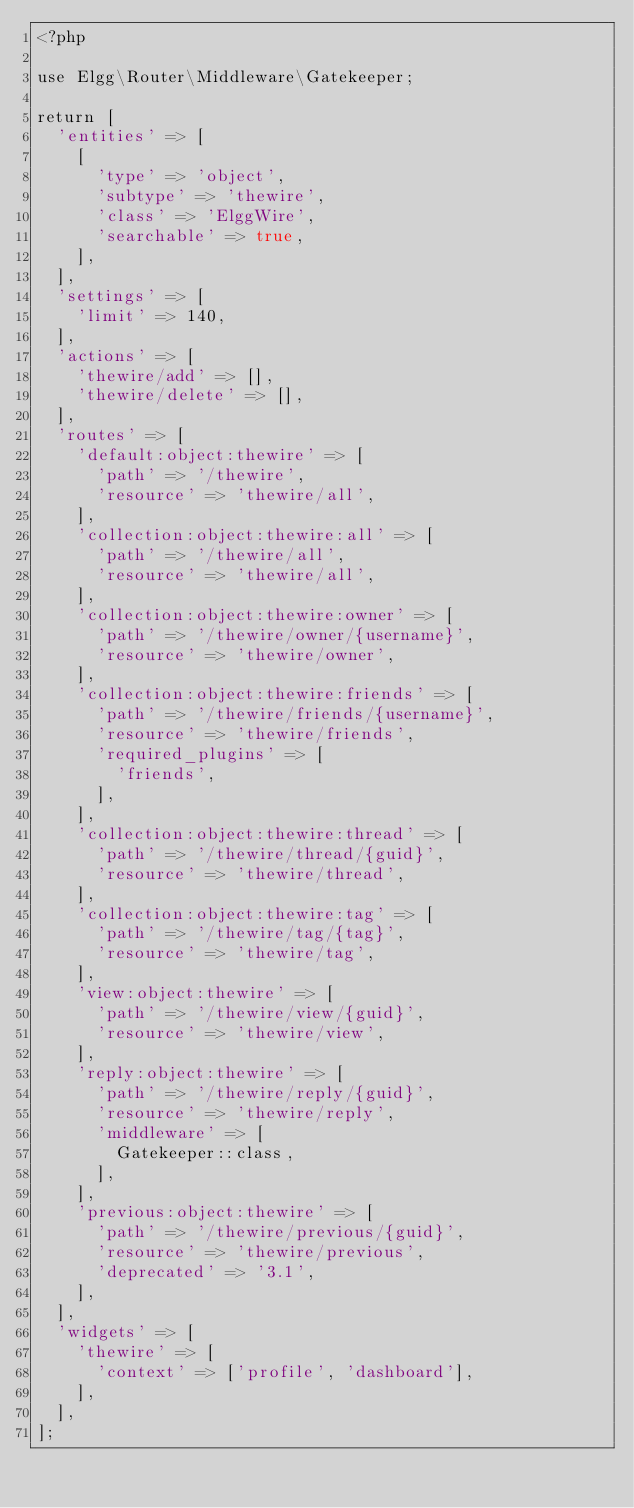<code> <loc_0><loc_0><loc_500><loc_500><_PHP_><?php

use Elgg\Router\Middleware\Gatekeeper;

return [
	'entities' => [
		[
			'type' => 'object',
			'subtype' => 'thewire',
			'class' => 'ElggWire',
			'searchable' => true,
		],
	],
	'settings' => [
		'limit' => 140,
	],
	'actions' => [
		'thewire/add' => [],
		'thewire/delete' => [],
	],
	'routes' => [
		'default:object:thewire' => [
			'path' => '/thewire',
			'resource' => 'thewire/all',
		],
		'collection:object:thewire:all' => [
			'path' => '/thewire/all',
			'resource' => 'thewire/all',
		],
		'collection:object:thewire:owner' => [
			'path' => '/thewire/owner/{username}',
			'resource' => 'thewire/owner',
		],
		'collection:object:thewire:friends' => [
			'path' => '/thewire/friends/{username}',
			'resource' => 'thewire/friends',
			'required_plugins' => [
				'friends',
			],
		],
		'collection:object:thewire:thread' => [
			'path' => '/thewire/thread/{guid}',
			'resource' => 'thewire/thread',
		],
		'collection:object:thewire:tag' => [
			'path' => '/thewire/tag/{tag}',
			'resource' => 'thewire/tag',
		],
		'view:object:thewire' => [
			'path' => '/thewire/view/{guid}',
			'resource' => 'thewire/view',
		],
		'reply:object:thewire' => [
			'path' => '/thewire/reply/{guid}',
			'resource' => 'thewire/reply',
			'middleware' => [
				Gatekeeper::class,
			],
		],
		'previous:object:thewire' => [
			'path' => '/thewire/previous/{guid}',
			'resource' => 'thewire/previous',
			'deprecated' => '3.1',
		],
	],
	'widgets' => [
		'thewire' => [
			'context' => ['profile', 'dashboard'],
		],
	],
];
</code> 